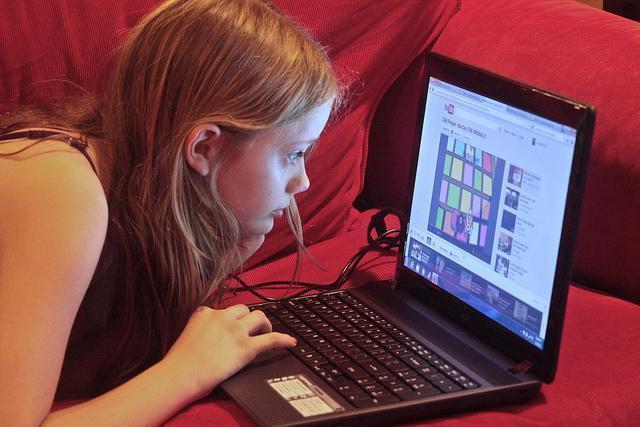How many laptops are on the table?
Give a very brief answer. 1. 